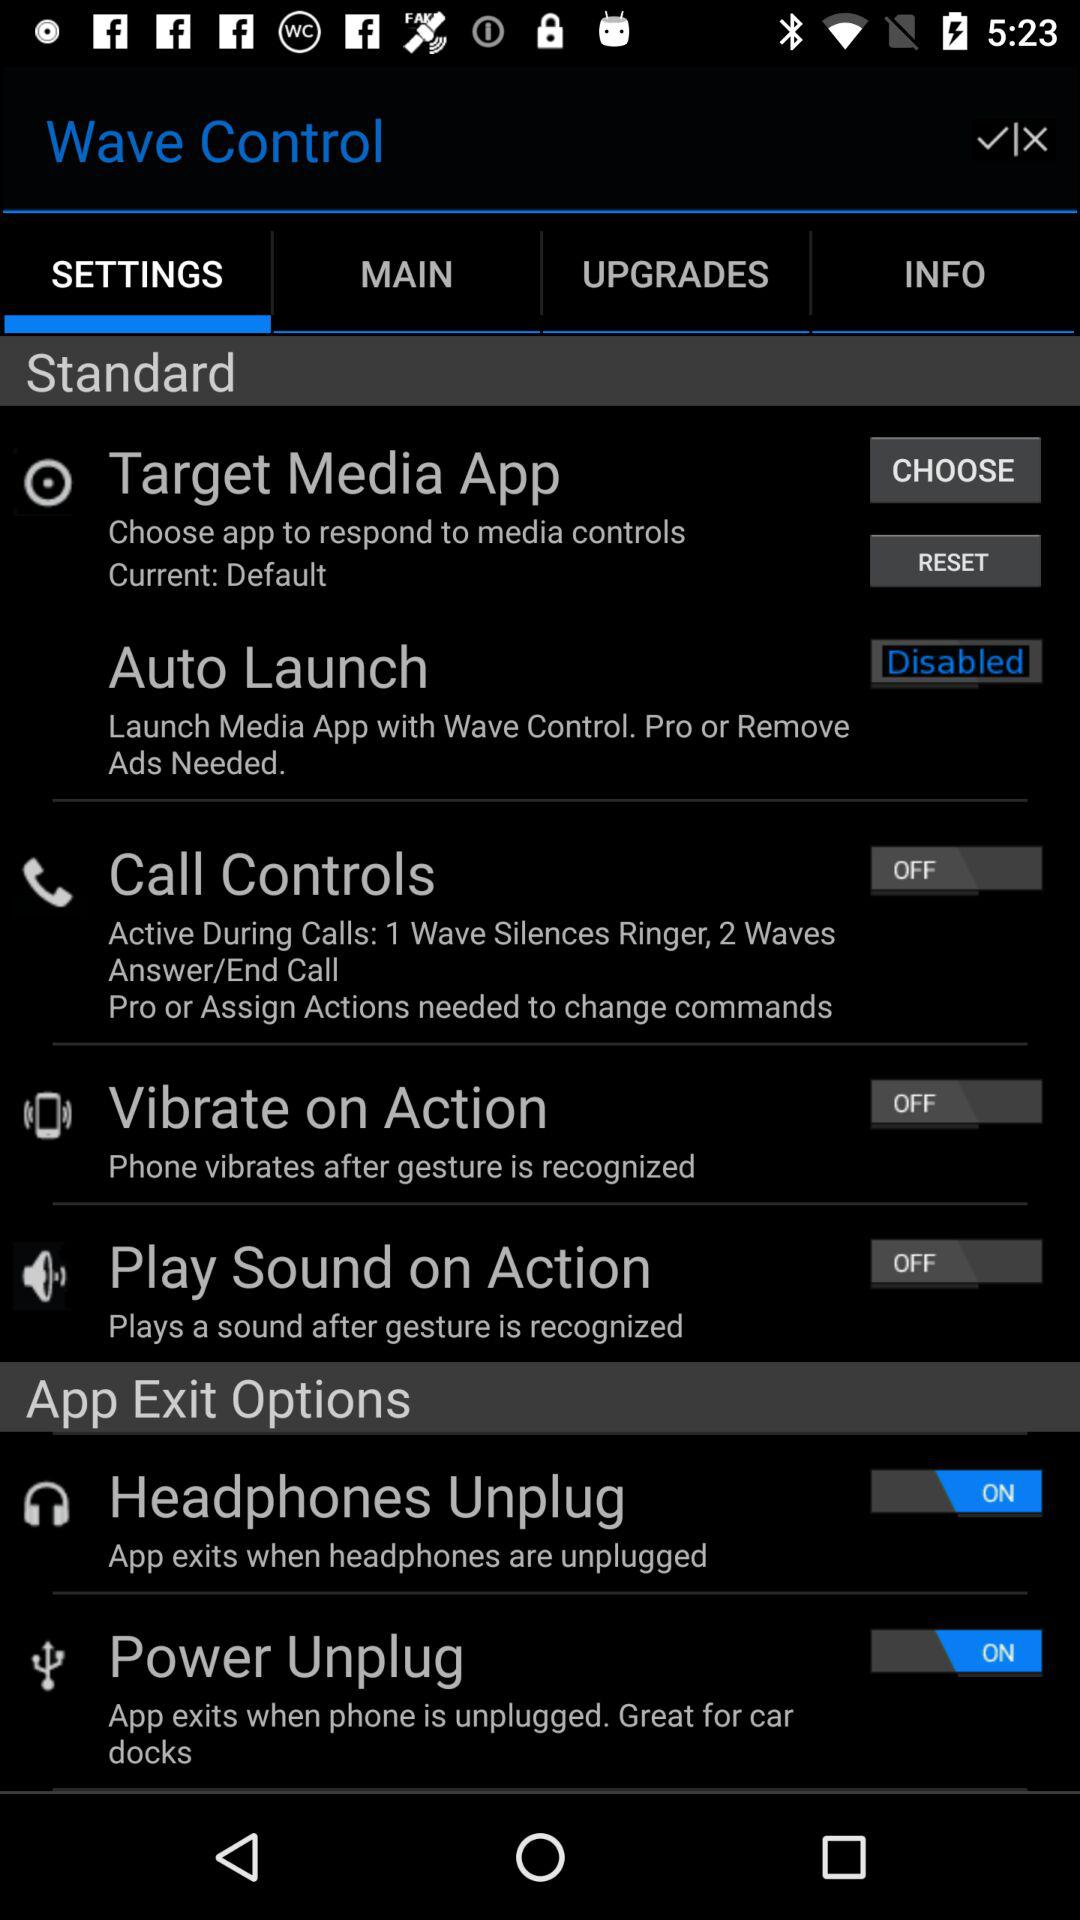Can you explain what the 'Vibrate on Action' setting does? The 'Vibrate on Action' setting, when enabled, makes the phone vibrate in response to a recognized gesture, providing tactile feedback that the gesture has been successfully registered. 